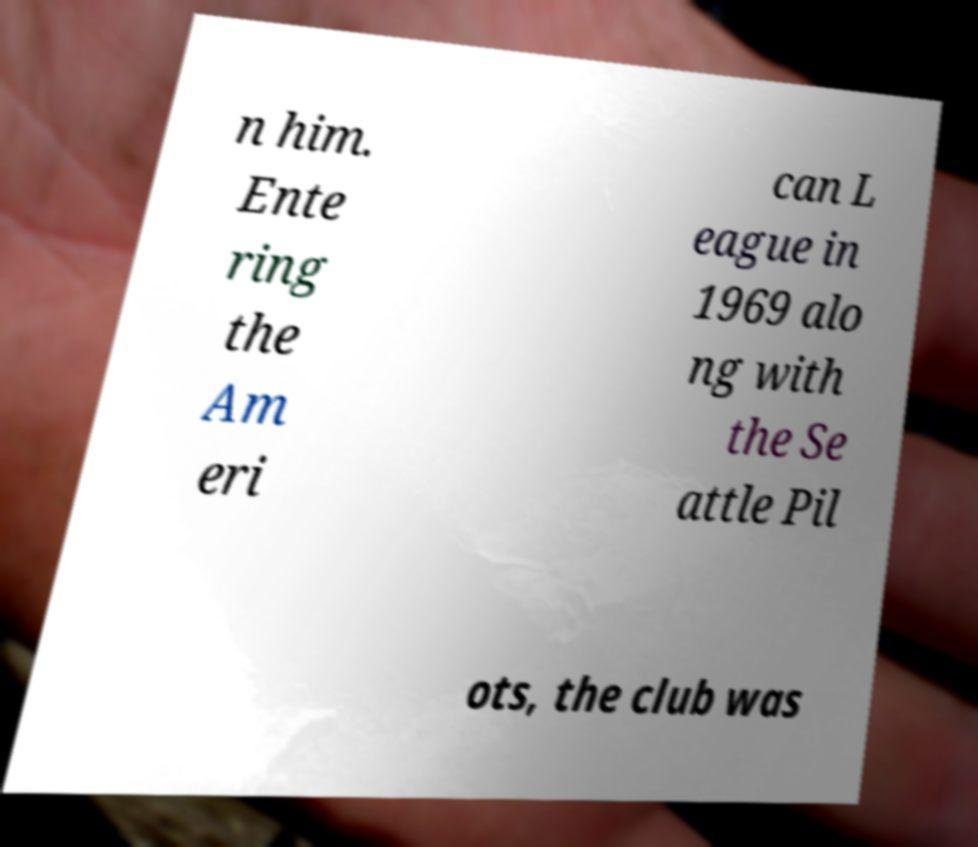Could you assist in decoding the text presented in this image and type it out clearly? n him. Ente ring the Am eri can L eague in 1969 alo ng with the Se attle Pil ots, the club was 